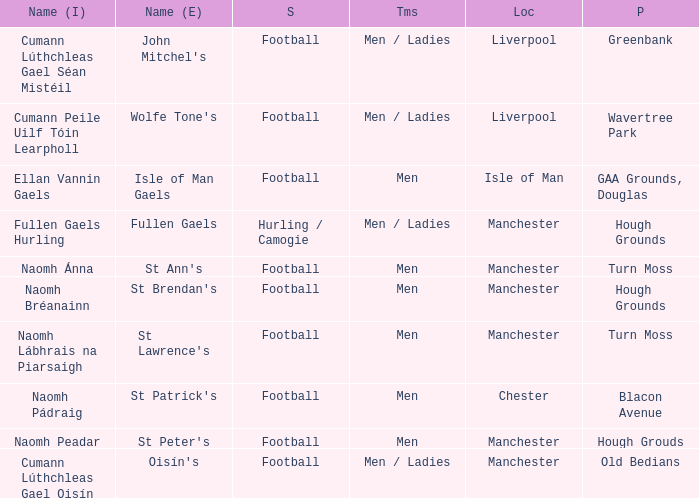What is the Location of the Old Bedians Pitch? Manchester. 